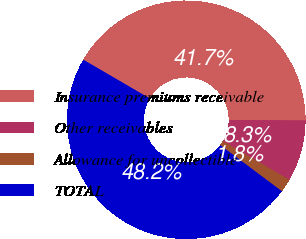Convert chart. <chart><loc_0><loc_0><loc_500><loc_500><pie_chart><fcel>Insurance premiums receivable<fcel>Other receivables<fcel>Allowance for uncollectible<fcel>TOTAL<nl><fcel>41.69%<fcel>8.31%<fcel>1.82%<fcel>48.18%<nl></chart> 